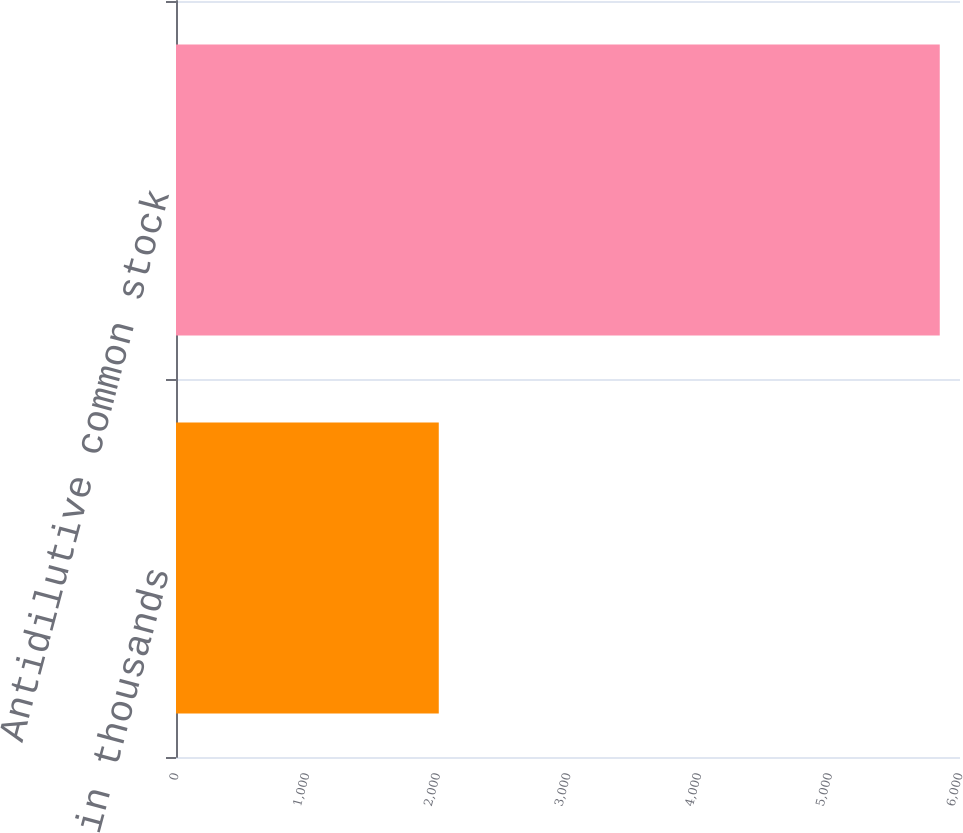Convert chart. <chart><loc_0><loc_0><loc_500><loc_500><bar_chart><fcel>in thousands<fcel>Antidilutive common stock<nl><fcel>2011<fcel>5845<nl></chart> 